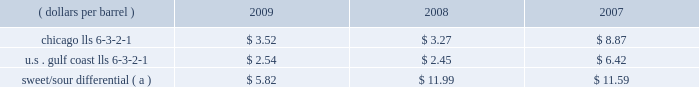Our refining and wholesale marketing gross margin is the difference between the prices of refined products sold and the costs of crude oil and other charge and blendstocks refined , including the costs to transport these inputs to our refineries , the costs of purchased products and manufacturing expenses , including depreciation .
The crack spread is a measure of the difference between market prices for refined products and crude oil , commonly used by the industry as a proxy for the refining margin .
Crack spreads can fluctuate significantly , particularly when prices of refined products do not move in the same relationship as the cost of crude oil .
As a performance benchmark and a comparison with other industry participants , we calculate midwest ( chicago ) and u.s .
Gulf coast crack spreads that we feel most closely track our operations and slate of products .
Posted light louisiana sweet ( 201clls 201d ) prices and a 6-3-2-1 ratio of products ( 6 barrels of crude oil producing 3 barrels of gasoline , 2 barrels of distillate and 1 barrel of residual fuel ) are used for the crack spread calculation .
Our refineries can process significant amounts of sour crude oil which typically can be purchased at a discount to sweet crude oil .
The amount of this discount , the sweet/sour differential , can vary significantly causing our refining and wholesale marketing gross margin to differ from the crack spreads which are based upon sweet crude .
In general , a larger sweet/sour differential will enhance our refining and wholesale marketing gross margin .
In 2009 , the sweet/sour differential narrowed , due to a variety of worldwide economic and petroleum industry related factors , primarily related to lower hydrocarbon demand .
Sour crude accounted for 50 percent , 52 percent and 54 percent of our crude oil processed in 2009 , 2008 and 2007 .
The table lists calculated average crack spreads for the midwest ( chicago ) and gulf coast markets and the sweet/sour differential for the past three years .
( dollars per barrel ) 2009 2008 2007 .
Sweet/sour differential ( a ) $ 5.82 $ 11.99 $ 11.59 ( a ) calculated using the following mix of crude types as compared to lls. : 15% ( 15 % ) arab light , 20% ( 20 % ) kuwait , 10% ( 10 % ) maya , 15% ( 15 % ) western canadian select , 40% ( 40 % ) mars .
In addition to the market changes indicated by the crack spreads and sweet/sour differential , our refining and wholesale marketing gross margin is impacted by factors such as : 2022 the types of crude oil and other charge and blendstocks processed , 2022 the selling prices realized for refined products , 2022 the impact of commodity derivative instruments used to manage price risk , 2022 the cost of products purchased for resale , and 2022 changes in manufacturing costs , which include depreciation .
Manufacturing costs are primarily driven by the cost of energy used by our refineries and the level of maintenance costs .
Planned turnaround and major maintenance activities were completed at our catlettsburg , garyville , and robinson refineries in 2009 .
We performed turnaround and major maintenance activities at our robinson , catlettsburg , garyville and canton refineries in 2008 and at our catlettsburg , robinson and st .
Paul park refineries in 2007 .
Our retail marketing gross margin for gasoline and distillates , which is the difference between the ultimate price paid by consumers and the cost of refined products , including secondary transportation and consumer excise taxes , also impacts rm&t segment profitability .
There are numerous factors including local competition , seasonal demand fluctuations , the available wholesale supply , the level of economic activity in our marketing areas and weather conditions that impact gasoline and distillate demand throughout the year .
Refined product demand increased for several years until 2008 when it decreased due to the combination of significant increases in retail petroleum prices , a broad slowdown in general economic activity , and the impact of increased ethanol blending into gasoline .
In 2009 refined product demand continued to decline .
For our marketing area , we estimate a gasoline demand decline of about one percent and a distillate demand decline of about 12 percent from 2008 levels .
Market demand declines for gasoline and distillates generally reduce the product margin we can realize .
We also estimate gasoline and distillate demand in our marketing area decreased about three percent in 2008 compared to 2007 levels .
The gross margin on merchandise sold at retail outlets has been historically less volatile. .
Sour crude percentage of our crude oil processed increased by how much between 2009 and 2008? 
Computations: (52 - 50)
Answer: 2.0. 